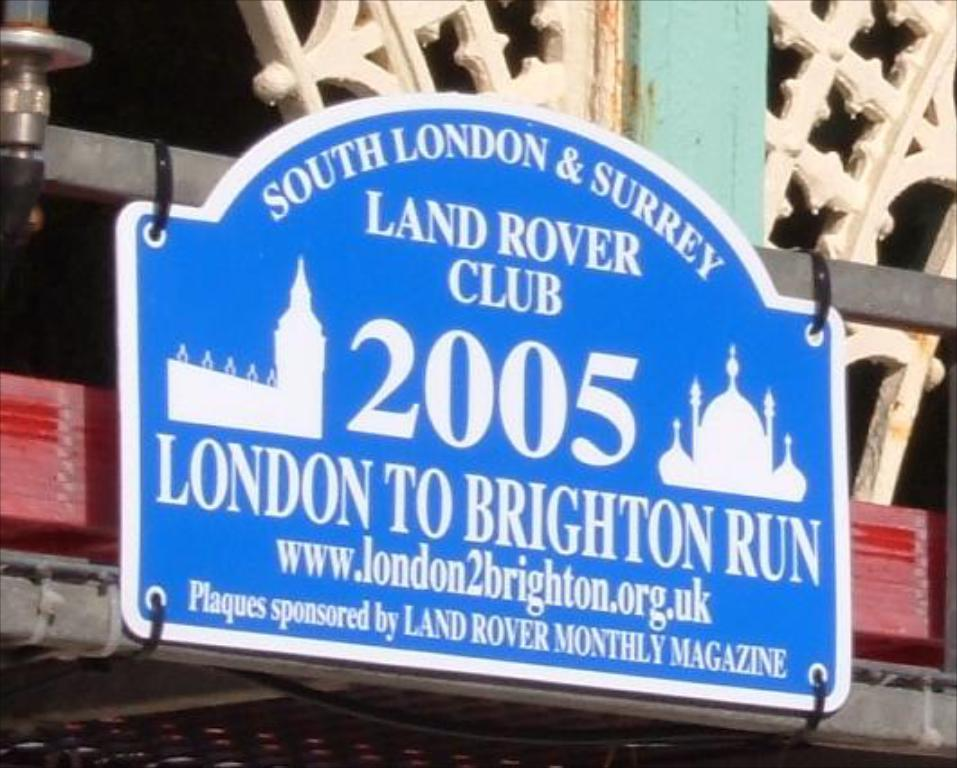Provide a one-sentence caption for the provided image. A blue plaque sponsored by Land Rover Monthly Magazine is tied to metal rods. 